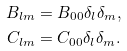Convert formula to latex. <formula><loc_0><loc_0><loc_500><loc_500>B _ { l m } & = B _ { 0 0 } \delta _ { l } \delta _ { m } , \\ C _ { l m } & = C _ { 0 0 } \delta _ { l } \delta _ { m } .</formula> 